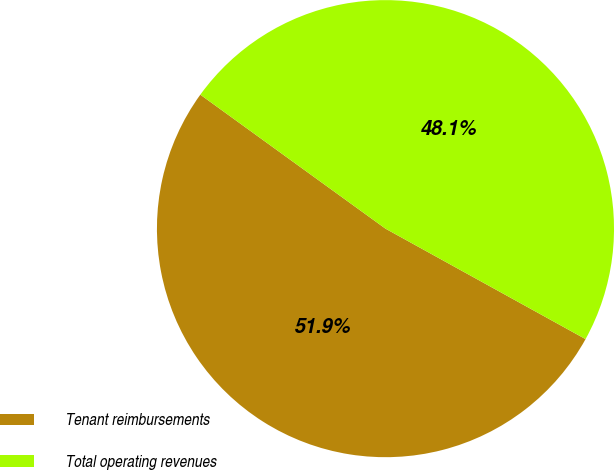Convert chart. <chart><loc_0><loc_0><loc_500><loc_500><pie_chart><fcel>Tenant reimbursements<fcel>Total operating revenues<nl><fcel>51.94%<fcel>48.06%<nl></chart> 